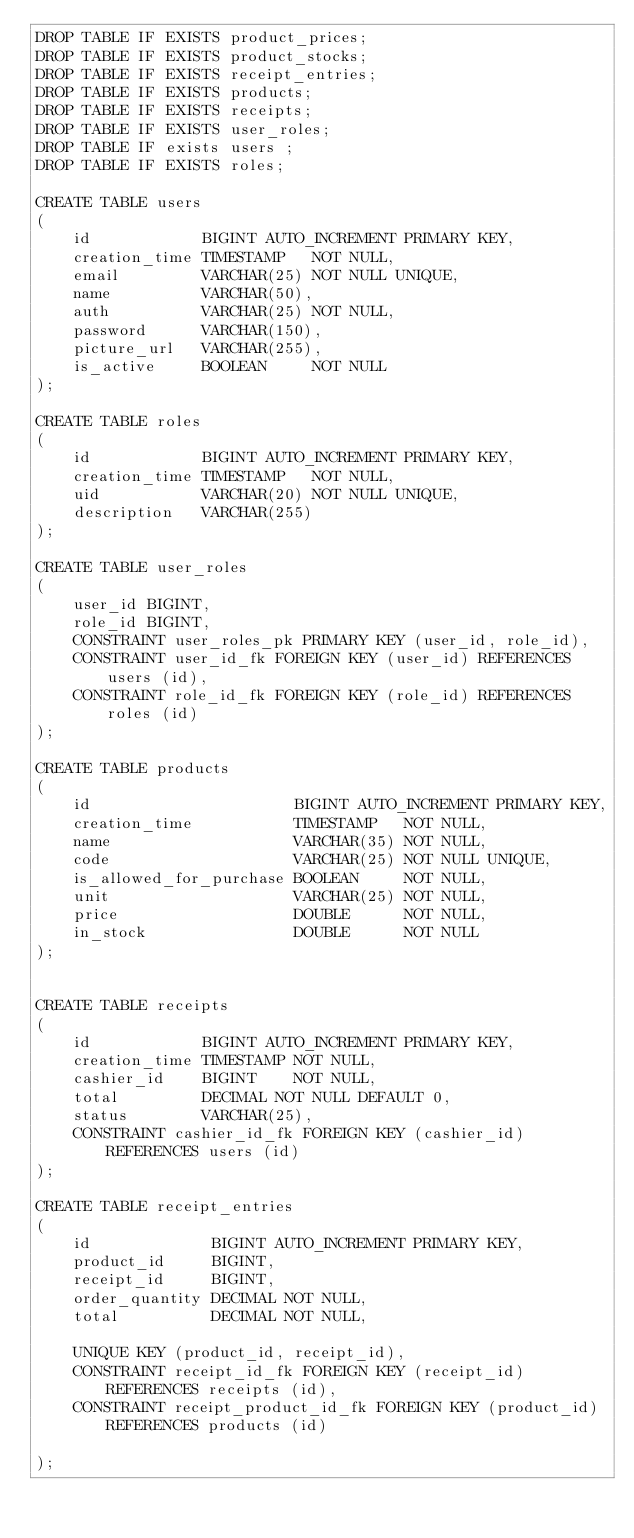Convert code to text. <code><loc_0><loc_0><loc_500><loc_500><_SQL_>DROP TABLE IF EXISTS product_prices;
DROP TABLE IF EXISTS product_stocks;
DROP TABLE IF EXISTS receipt_entries;
DROP TABLE IF EXISTS products;
DROP TABLE IF EXISTS receipts;
DROP TABLE IF EXISTS user_roles;
DROP TABLE IF exists users ;
DROP TABLE IF EXISTS roles;

CREATE TABLE users
(
    id            BIGINT AUTO_INCREMENT PRIMARY KEY,
    creation_time TIMESTAMP   NOT NULL,
    email         VARCHAR(25) NOT NULL UNIQUE,
    name          VARCHAR(50),
    auth          VARCHAR(25) NOT NULL,
    password      VARCHAR(150),
    picture_url   VARCHAR(255),
    is_active     BOOLEAN     NOT NULL
);

CREATE TABLE roles
(
    id            BIGINT AUTO_INCREMENT PRIMARY KEY,
    creation_time TIMESTAMP   NOT NULL,
    uid           VARCHAR(20) NOT NULL UNIQUE,
    description   VARCHAR(255)
);

CREATE TABLE user_roles
(
    user_id BIGINT,
    role_id BIGINT,
    CONSTRAINT user_roles_pk PRIMARY KEY (user_id, role_id),
    CONSTRAINT user_id_fk FOREIGN KEY (user_id) REFERENCES users (id),
    CONSTRAINT role_id_fk FOREIGN KEY (role_id) REFERENCES roles (id)
);

CREATE TABLE products
(
    id                      BIGINT AUTO_INCREMENT PRIMARY KEY,
    creation_time           TIMESTAMP   NOT NULL,
    name                    VARCHAR(35) NOT NULL,
    code                    VARCHAR(25) NOT NULL UNIQUE,
    is_allowed_for_purchase BOOLEAN     NOT NULL,
    unit                    VARCHAR(25) NOT NULL,
    price                   DOUBLE      NOT NULL,
    in_stock                DOUBLE      NOT NULL
);


CREATE TABLE receipts
(
    id            BIGINT AUTO_INCREMENT PRIMARY KEY,
    creation_time TIMESTAMP NOT NULL,
    cashier_id    BIGINT    NOT NULL,
    total         DECIMAL NOT NULL DEFAULT 0,
    status        VARCHAR(25),
    CONSTRAINT cashier_id_fk FOREIGN KEY (cashier_id) REFERENCES users (id)
);

CREATE TABLE receipt_entries
(
    id             BIGINT AUTO_INCREMENT PRIMARY KEY,
    product_id     BIGINT,
    receipt_id     BIGINT,
    order_quantity DECIMAL NOT NULL,
    total          DECIMAL NOT NULL,

    UNIQUE KEY (product_id, receipt_id),
    CONSTRAINT receipt_id_fk FOREIGN KEY (receipt_id) REFERENCES receipts (id),
    CONSTRAINT receipt_product_id_fk FOREIGN KEY (product_id) REFERENCES products (id)

);


</code> 